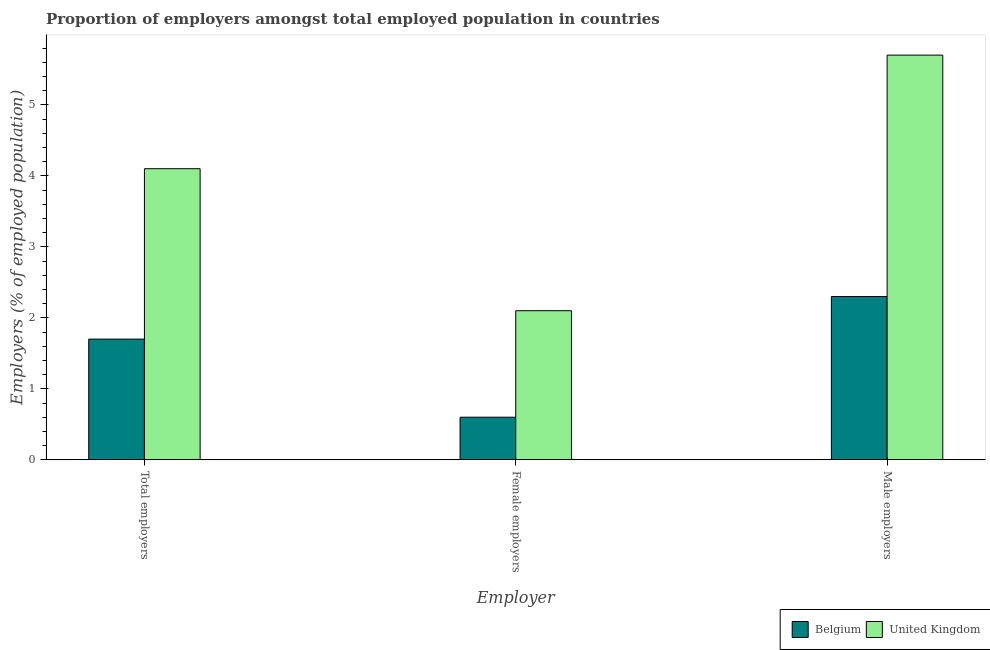What is the label of the 2nd group of bars from the left?
Your response must be concise. Female employers. What is the percentage of female employers in United Kingdom?
Your response must be concise. 2.1. Across all countries, what is the maximum percentage of female employers?
Provide a short and direct response. 2.1. Across all countries, what is the minimum percentage of male employers?
Provide a short and direct response. 2.3. In which country was the percentage of female employers maximum?
Offer a terse response. United Kingdom. What is the total percentage of total employers in the graph?
Keep it short and to the point. 5.8. What is the difference between the percentage of female employers in Belgium and that in United Kingdom?
Offer a very short reply. -1.5. What is the difference between the percentage of total employers in Belgium and the percentage of male employers in United Kingdom?
Provide a succinct answer. -4. What is the average percentage of female employers per country?
Provide a short and direct response. 1.35. What is the difference between the percentage of male employers and percentage of total employers in United Kingdom?
Offer a very short reply. 1.6. What is the ratio of the percentage of male employers in United Kingdom to that in Belgium?
Your answer should be very brief. 2.48. Is the percentage of female employers in Belgium less than that in United Kingdom?
Offer a terse response. Yes. Is the difference between the percentage of total employers in Belgium and United Kingdom greater than the difference between the percentage of female employers in Belgium and United Kingdom?
Make the answer very short. No. What is the difference between the highest and the second highest percentage of total employers?
Make the answer very short. 2.4. What is the difference between the highest and the lowest percentage of total employers?
Your response must be concise. 2.4. How many bars are there?
Provide a succinct answer. 6. Are all the bars in the graph horizontal?
Your answer should be compact. No. What is the difference between two consecutive major ticks on the Y-axis?
Make the answer very short. 1. Are the values on the major ticks of Y-axis written in scientific E-notation?
Your answer should be compact. No. How many legend labels are there?
Your answer should be compact. 2. What is the title of the graph?
Ensure brevity in your answer.  Proportion of employers amongst total employed population in countries. Does "Jordan" appear as one of the legend labels in the graph?
Give a very brief answer. No. What is the label or title of the X-axis?
Offer a terse response. Employer. What is the label or title of the Y-axis?
Provide a succinct answer. Employers (% of employed population). What is the Employers (% of employed population) of Belgium in Total employers?
Give a very brief answer. 1.7. What is the Employers (% of employed population) of United Kingdom in Total employers?
Give a very brief answer. 4.1. What is the Employers (% of employed population) of Belgium in Female employers?
Provide a succinct answer. 0.6. What is the Employers (% of employed population) of United Kingdom in Female employers?
Keep it short and to the point. 2.1. What is the Employers (% of employed population) of Belgium in Male employers?
Provide a short and direct response. 2.3. What is the Employers (% of employed population) in United Kingdom in Male employers?
Keep it short and to the point. 5.7. Across all Employer, what is the maximum Employers (% of employed population) of Belgium?
Provide a short and direct response. 2.3. Across all Employer, what is the maximum Employers (% of employed population) of United Kingdom?
Your answer should be very brief. 5.7. Across all Employer, what is the minimum Employers (% of employed population) of Belgium?
Your answer should be compact. 0.6. Across all Employer, what is the minimum Employers (% of employed population) of United Kingdom?
Ensure brevity in your answer.  2.1. What is the total Employers (% of employed population) of United Kingdom in the graph?
Provide a succinct answer. 11.9. What is the difference between the Employers (% of employed population) in United Kingdom in Total employers and that in Female employers?
Provide a short and direct response. 2. What is the difference between the Employers (% of employed population) in Belgium in Total employers and that in Male employers?
Your response must be concise. -0.6. What is the difference between the Employers (% of employed population) in Belgium in Total employers and the Employers (% of employed population) in United Kingdom in Male employers?
Give a very brief answer. -4. What is the difference between the Employers (% of employed population) of Belgium in Female employers and the Employers (% of employed population) of United Kingdom in Male employers?
Provide a short and direct response. -5.1. What is the average Employers (% of employed population) in Belgium per Employer?
Your answer should be compact. 1.53. What is the average Employers (% of employed population) of United Kingdom per Employer?
Make the answer very short. 3.97. What is the difference between the Employers (% of employed population) in Belgium and Employers (% of employed population) in United Kingdom in Male employers?
Offer a very short reply. -3.4. What is the ratio of the Employers (% of employed population) in Belgium in Total employers to that in Female employers?
Your response must be concise. 2.83. What is the ratio of the Employers (% of employed population) of United Kingdom in Total employers to that in Female employers?
Ensure brevity in your answer.  1.95. What is the ratio of the Employers (% of employed population) in Belgium in Total employers to that in Male employers?
Keep it short and to the point. 0.74. What is the ratio of the Employers (% of employed population) of United Kingdom in Total employers to that in Male employers?
Your answer should be very brief. 0.72. What is the ratio of the Employers (% of employed population) in Belgium in Female employers to that in Male employers?
Make the answer very short. 0.26. What is the ratio of the Employers (% of employed population) of United Kingdom in Female employers to that in Male employers?
Give a very brief answer. 0.37. What is the difference between the highest and the second highest Employers (% of employed population) in Belgium?
Offer a very short reply. 0.6. What is the difference between the highest and the lowest Employers (% of employed population) of Belgium?
Your response must be concise. 1.7. What is the difference between the highest and the lowest Employers (% of employed population) in United Kingdom?
Your answer should be very brief. 3.6. 